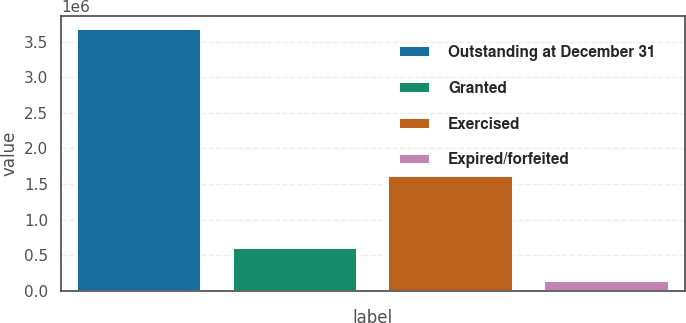<chart> <loc_0><loc_0><loc_500><loc_500><bar_chart><fcel>Outstanding at December 31<fcel>Granted<fcel>Exercised<fcel>Expired/forfeited<nl><fcel>3.68296e+06<fcel>603230<fcel>1.606e+06<fcel>129564<nl></chart> 